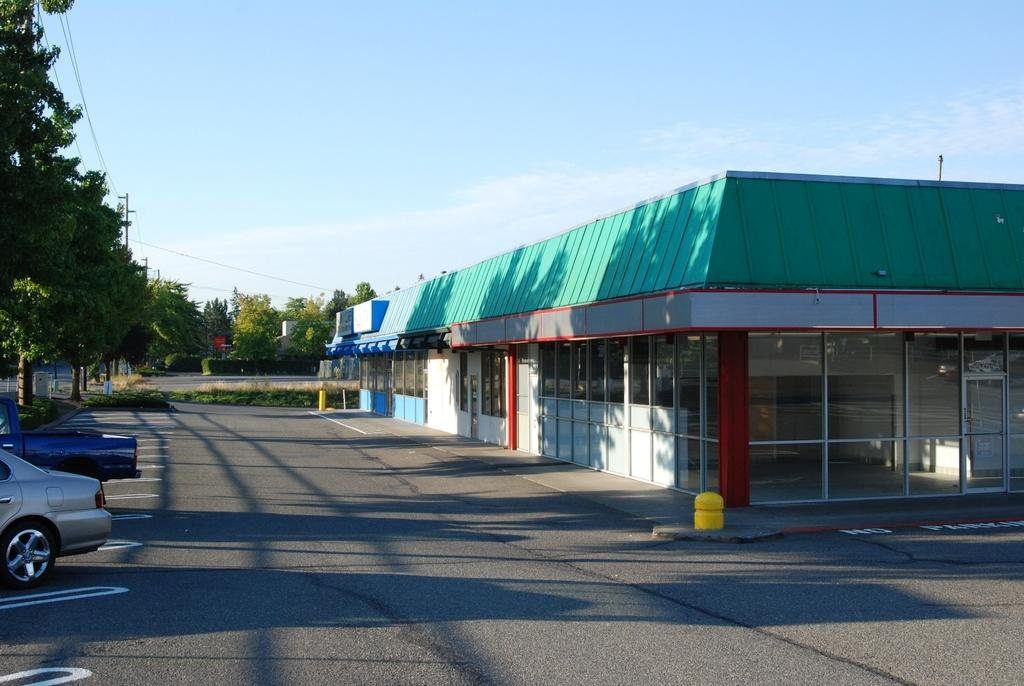What type of structure is present in the image? There is a building in the image. What are the vertical supports in the image? There are poles in the image. What type of vegetation is present in the image? There are trees in the image. What type of ground cover is present in the image? There is grass in the image. What are the thin, elongated objects in the image? There are wires in the image. What type of transportation is present in the image? There are vehicles in the image. What can be seen in the background of the image? The sky with clouds is visible in the background of the image. What type of distribution system is present in the image? There is no distribution system present in the image. What type of group is depicted in the image? There is no group of people or animals depicted in the image. What type of acoustics can be heard in the image? There is no sound or audio present in the image, so it is not possible to determine the acoustics. 